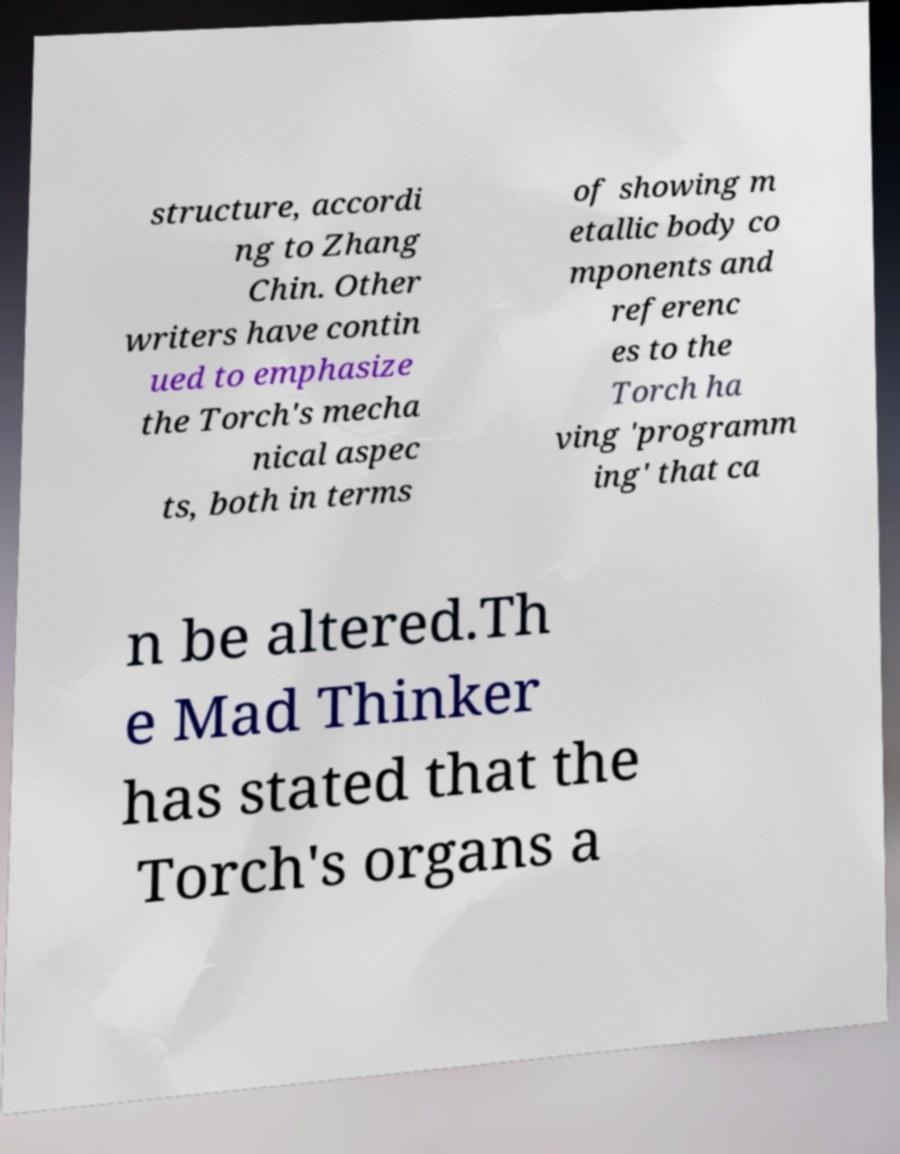There's text embedded in this image that I need extracted. Can you transcribe it verbatim? structure, accordi ng to Zhang Chin. Other writers have contin ued to emphasize the Torch's mecha nical aspec ts, both in terms of showing m etallic body co mponents and referenc es to the Torch ha ving 'programm ing' that ca n be altered.Th e Mad Thinker has stated that the Torch's organs a 